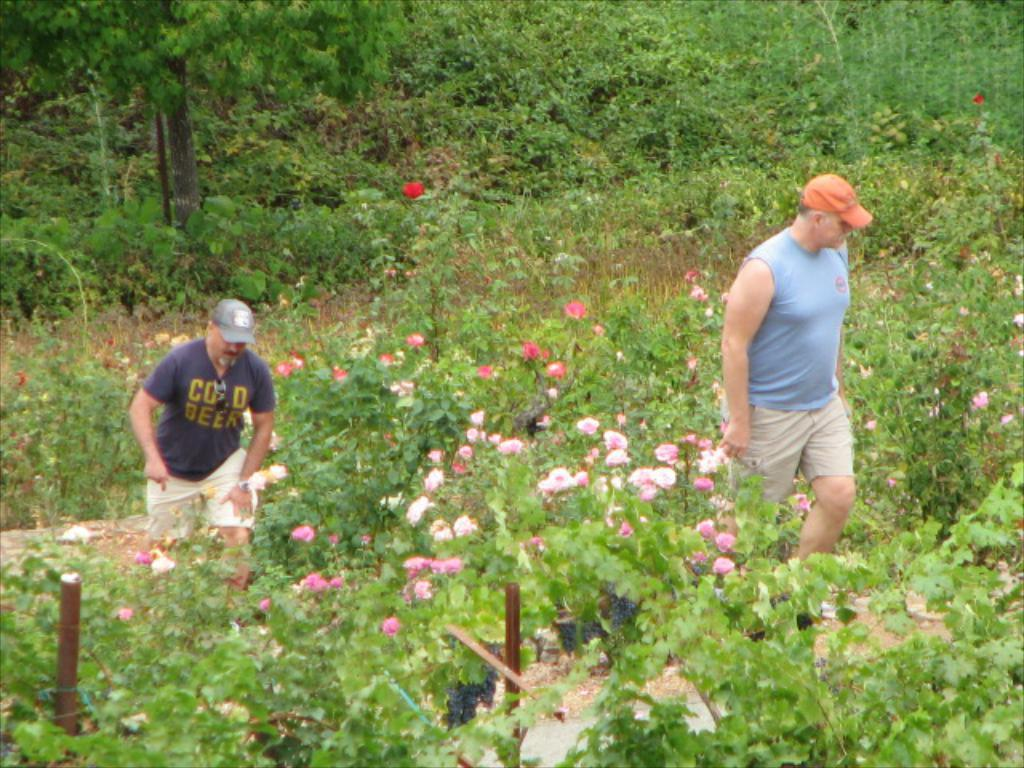How many people are present in the image? There are two people in the image. What can be seen besides the people in the image? There are plants with flowers in the image. What is visible in the background of the image? There are trees in the background of the image. What type of crow can be seen resting on the shoulder of one of the people in the image? There is no crow present in the image; it only features two people and plants with flowers. 